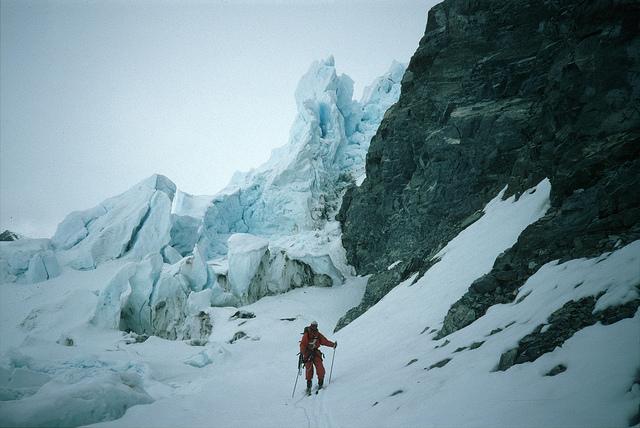Where is the person standing?
Concise answer only. Mountain. Which hand is raised in the air?
Be succinct. Left. What activity is the person in the photo partaking in?
Keep it brief. Skiing. Is it snowing?
Give a very brief answer. No. Is this the best time of day to tell if there are craters in the rocks around one?
Quick response, please. No. Where is this picture taken?
Short answer required. Mountain. 